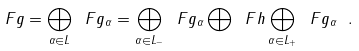Convert formula to latex. <formula><loc_0><loc_0><loc_500><loc_500>\ F g = \bigoplus _ { \alpha \in L } \ F g _ { \alpha } = \bigoplus _ { \alpha \in L _ { - } } \ F g _ { \alpha } \bigoplus \ F h \bigoplus _ { \alpha \in L _ { + } } \ F g _ { \alpha } \ .</formula> 